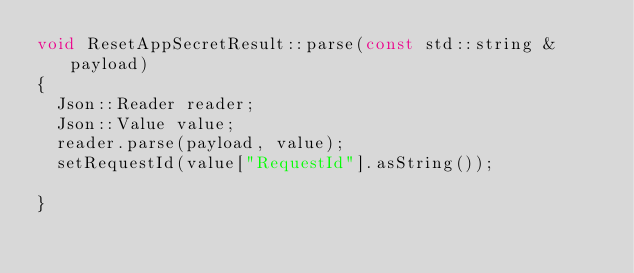Convert code to text. <code><loc_0><loc_0><loc_500><loc_500><_C++_>void ResetAppSecretResult::parse(const std::string &payload)
{
	Json::Reader reader;
	Json::Value value;
	reader.parse(payload, value);
	setRequestId(value["RequestId"].asString());

}

</code> 